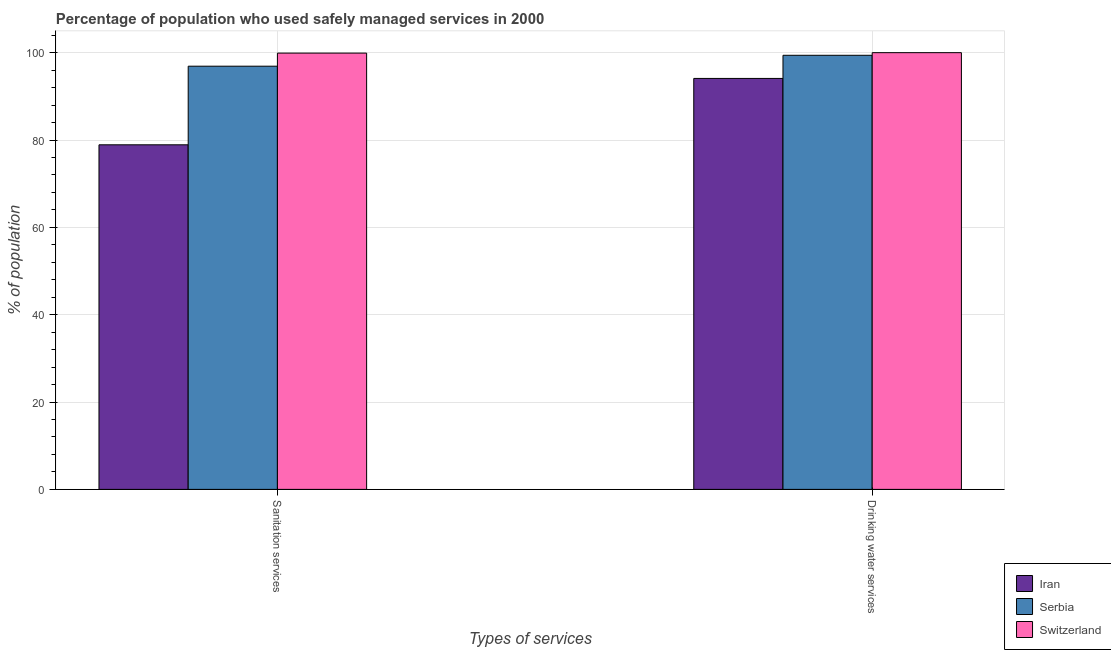How many groups of bars are there?
Provide a short and direct response. 2. Are the number of bars on each tick of the X-axis equal?
Offer a terse response. Yes. What is the label of the 1st group of bars from the left?
Keep it short and to the point. Sanitation services. What is the percentage of population who used drinking water services in Iran?
Provide a succinct answer. 94.1. Across all countries, what is the maximum percentage of population who used drinking water services?
Your response must be concise. 100. Across all countries, what is the minimum percentage of population who used drinking water services?
Keep it short and to the point. 94.1. In which country was the percentage of population who used sanitation services maximum?
Your answer should be very brief. Switzerland. In which country was the percentage of population who used drinking water services minimum?
Your response must be concise. Iran. What is the total percentage of population who used sanitation services in the graph?
Offer a terse response. 275.7. What is the difference between the percentage of population who used drinking water services in Switzerland and the percentage of population who used sanitation services in Iran?
Make the answer very short. 21.1. What is the average percentage of population who used drinking water services per country?
Provide a short and direct response. 97.83. What is the difference between the percentage of population who used sanitation services and percentage of population who used drinking water services in Switzerland?
Offer a terse response. -0.1. In how many countries, is the percentage of population who used drinking water services greater than 20 %?
Your answer should be very brief. 3. What is the ratio of the percentage of population who used sanitation services in Switzerland to that in Iran?
Keep it short and to the point. 1.27. Is the percentage of population who used sanitation services in Serbia less than that in Iran?
Give a very brief answer. No. In how many countries, is the percentage of population who used drinking water services greater than the average percentage of population who used drinking water services taken over all countries?
Your response must be concise. 2. What does the 2nd bar from the left in Drinking water services represents?
Ensure brevity in your answer.  Serbia. What does the 1st bar from the right in Drinking water services represents?
Offer a very short reply. Switzerland. How many bars are there?
Your response must be concise. 6. Are all the bars in the graph horizontal?
Provide a short and direct response. No. How many countries are there in the graph?
Provide a short and direct response. 3. What is the difference between two consecutive major ticks on the Y-axis?
Give a very brief answer. 20. Does the graph contain any zero values?
Keep it short and to the point. No. Does the graph contain grids?
Keep it short and to the point. Yes. Where does the legend appear in the graph?
Ensure brevity in your answer.  Bottom right. What is the title of the graph?
Your answer should be compact. Percentage of population who used safely managed services in 2000. Does "Bolivia" appear as one of the legend labels in the graph?
Your response must be concise. No. What is the label or title of the X-axis?
Your answer should be very brief. Types of services. What is the label or title of the Y-axis?
Provide a short and direct response. % of population. What is the % of population in Iran in Sanitation services?
Offer a very short reply. 78.9. What is the % of population in Serbia in Sanitation services?
Provide a short and direct response. 96.9. What is the % of population in Switzerland in Sanitation services?
Ensure brevity in your answer.  99.9. What is the % of population of Iran in Drinking water services?
Your response must be concise. 94.1. What is the % of population in Serbia in Drinking water services?
Offer a very short reply. 99.4. What is the % of population in Switzerland in Drinking water services?
Your answer should be very brief. 100. Across all Types of services, what is the maximum % of population in Iran?
Provide a succinct answer. 94.1. Across all Types of services, what is the maximum % of population in Serbia?
Offer a very short reply. 99.4. Across all Types of services, what is the maximum % of population of Switzerland?
Ensure brevity in your answer.  100. Across all Types of services, what is the minimum % of population of Iran?
Make the answer very short. 78.9. Across all Types of services, what is the minimum % of population in Serbia?
Offer a very short reply. 96.9. Across all Types of services, what is the minimum % of population of Switzerland?
Your answer should be very brief. 99.9. What is the total % of population in Iran in the graph?
Your answer should be very brief. 173. What is the total % of population of Serbia in the graph?
Your answer should be compact. 196.3. What is the total % of population in Switzerland in the graph?
Make the answer very short. 199.9. What is the difference between the % of population of Iran in Sanitation services and that in Drinking water services?
Make the answer very short. -15.2. What is the difference between the % of population of Serbia in Sanitation services and that in Drinking water services?
Your answer should be compact. -2.5. What is the difference between the % of population in Iran in Sanitation services and the % of population in Serbia in Drinking water services?
Provide a succinct answer. -20.5. What is the difference between the % of population in Iran in Sanitation services and the % of population in Switzerland in Drinking water services?
Your answer should be very brief. -21.1. What is the difference between the % of population of Serbia in Sanitation services and the % of population of Switzerland in Drinking water services?
Give a very brief answer. -3.1. What is the average % of population of Iran per Types of services?
Give a very brief answer. 86.5. What is the average % of population of Serbia per Types of services?
Give a very brief answer. 98.15. What is the average % of population of Switzerland per Types of services?
Keep it short and to the point. 99.95. What is the difference between the % of population in Iran and % of population in Serbia in Sanitation services?
Ensure brevity in your answer.  -18. What is the difference between the % of population of Iran and % of population of Switzerland in Sanitation services?
Give a very brief answer. -21. What is the difference between the % of population in Serbia and % of population in Switzerland in Sanitation services?
Provide a short and direct response. -3. What is the difference between the % of population of Iran and % of population of Serbia in Drinking water services?
Ensure brevity in your answer.  -5.3. What is the ratio of the % of population of Iran in Sanitation services to that in Drinking water services?
Your answer should be compact. 0.84. What is the ratio of the % of population of Serbia in Sanitation services to that in Drinking water services?
Offer a terse response. 0.97. What is the ratio of the % of population in Switzerland in Sanitation services to that in Drinking water services?
Ensure brevity in your answer.  1. What is the difference between the highest and the second highest % of population in Switzerland?
Provide a short and direct response. 0.1. What is the difference between the highest and the lowest % of population of Switzerland?
Provide a succinct answer. 0.1. 